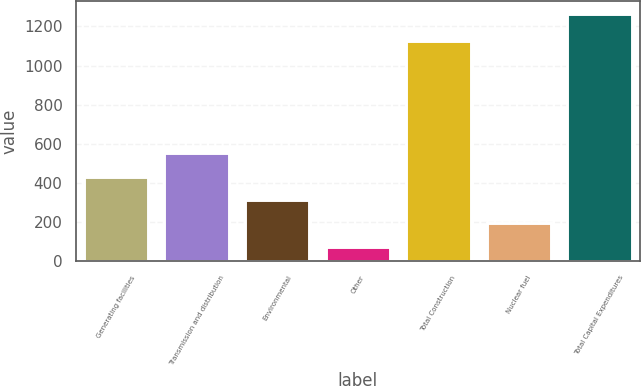Convert chart to OTSL. <chart><loc_0><loc_0><loc_500><loc_500><bar_chart><fcel>Generating facilities<fcel>Transmission and distribution<fcel>Environmental<fcel>Other<fcel>Total Construction<fcel>Nuclear fuel<fcel>Total Capital Expenditures<nl><fcel>432<fcel>551<fcel>313<fcel>75<fcel>1125<fcel>194<fcel>1265<nl></chart> 